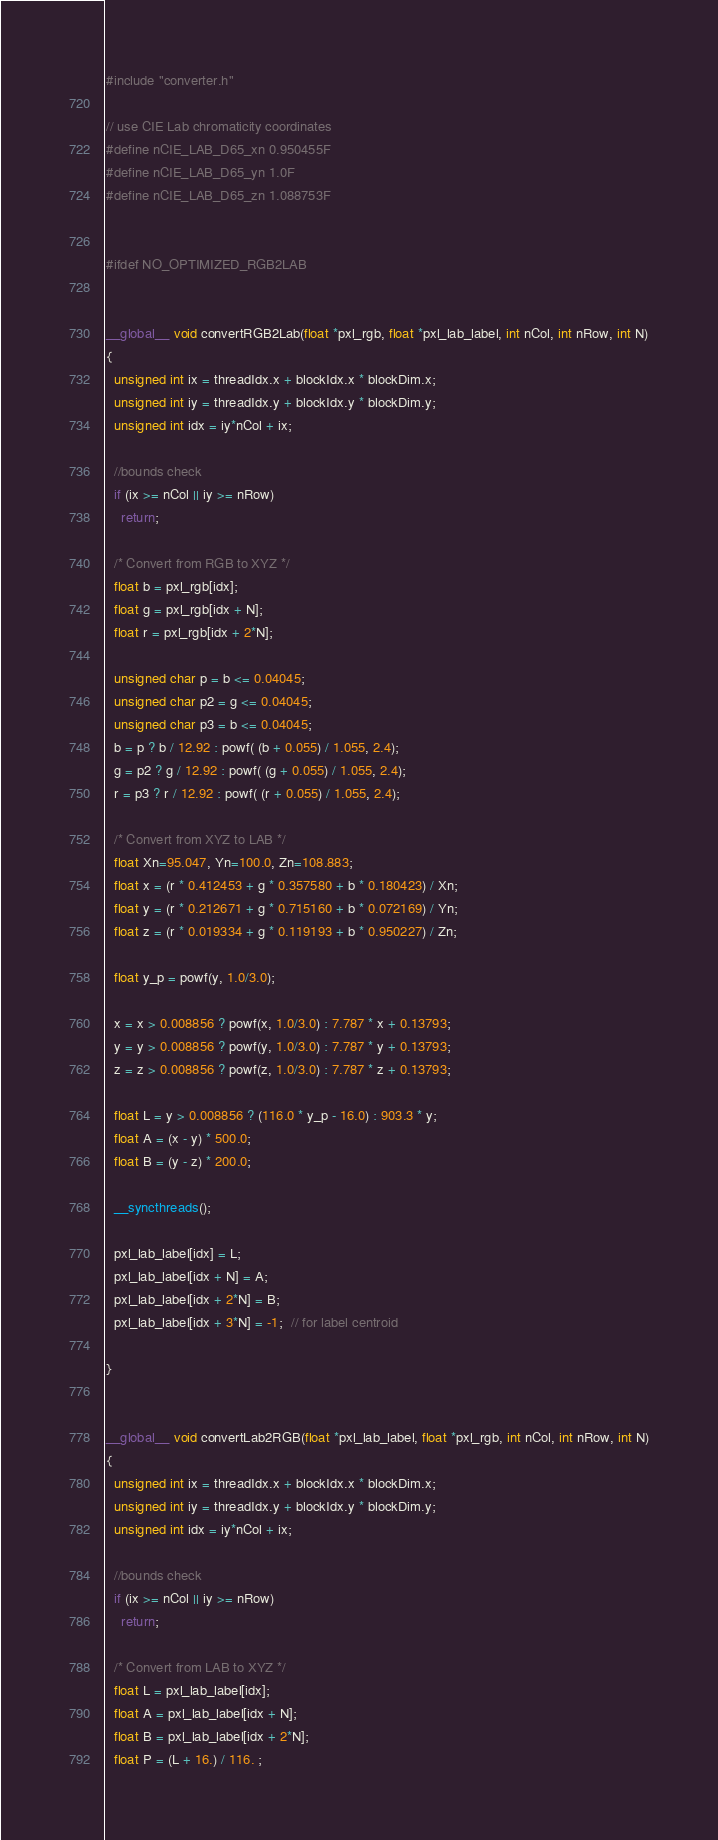Convert code to text. <code><loc_0><loc_0><loc_500><loc_500><_Cuda_>#include "converter.h"

// use CIE Lab chromaticity coordinates
#define nCIE_LAB_D65_xn 0.950455F
#define nCIE_LAB_D65_yn 1.0F
#define nCIE_LAB_D65_zn 1.088753F


#ifdef NO_OPTIMIZED_RGB2LAB


__global__ void convertRGB2Lab(float *pxl_rgb, float *pxl_lab_label, int nCol, int nRow, int N)
{
  unsigned int ix = threadIdx.x + blockIdx.x * blockDim.x;
  unsigned int iy = threadIdx.y + blockIdx.y * blockDim.y;
  unsigned int idx = iy*nCol + ix;

  //bounds check
  if (ix >= nCol || iy >= nRow)
    return;

  /* Convert from RGB to XYZ */
  float b = pxl_rgb[idx];
  float g = pxl_rgb[idx + N];
  float r = pxl_rgb[idx + 2*N];

  unsigned char p = b <= 0.04045;
  unsigned char p2 = g <= 0.04045;
  unsigned char p3 = b <= 0.04045;
  b = p ? b / 12.92 : powf( (b + 0.055) / 1.055, 2.4);
  g = p2 ? g / 12.92 : powf( (g + 0.055) / 1.055, 2.4);
  r = p3 ? r / 12.92 : powf( (r + 0.055) / 1.055, 2.4);

  /* Convert from XYZ to LAB */
  float Xn=95.047, Yn=100.0, Zn=108.883;
  float x = (r * 0.412453 + g * 0.357580 + b * 0.180423) / Xn;
  float y = (r * 0.212671 + g * 0.715160 + b * 0.072169) / Yn;
  float z = (r * 0.019334 + g * 0.119193 + b * 0.950227) / Zn;

  float y_p = powf(y, 1.0/3.0);

  x = x > 0.008856 ? powf(x, 1.0/3.0) : 7.787 * x + 0.13793;
  y = y > 0.008856 ? powf(y, 1.0/3.0) : 7.787 * y + 0.13793;
  z = z > 0.008856 ? powf(z, 1.0/3.0) : 7.787 * z + 0.13793;

  float L = y > 0.008856 ? (116.0 * y_p - 16.0) : 903.3 * y;
  float A = (x - y) * 500.0;
  float B = (y - z) * 200.0;

  __syncthreads();

  pxl_lab_label[idx] = L;
  pxl_lab_label[idx + N] = A;
  pxl_lab_label[idx + 2*N] = B;
  pxl_lab_label[idx + 3*N] = -1;  // for label centroid

}


__global__ void convertLab2RGB(float *pxl_lab_label, float *pxl_rgb, int nCol, int nRow, int N)
{
  unsigned int ix = threadIdx.x + blockIdx.x * blockDim.x;
  unsigned int iy = threadIdx.y + blockIdx.y * blockDim.y;
  unsigned int idx = iy*nCol + ix;

  //bounds check
  if (ix >= nCol || iy >= nRow)
    return;

  /* Convert from LAB to XYZ */
  float L = pxl_lab_label[idx];
  float A = pxl_lab_label[idx + N];
  float B = pxl_lab_label[idx + 2*N];
  float P = (L + 16.) / 116. ;
</code> 